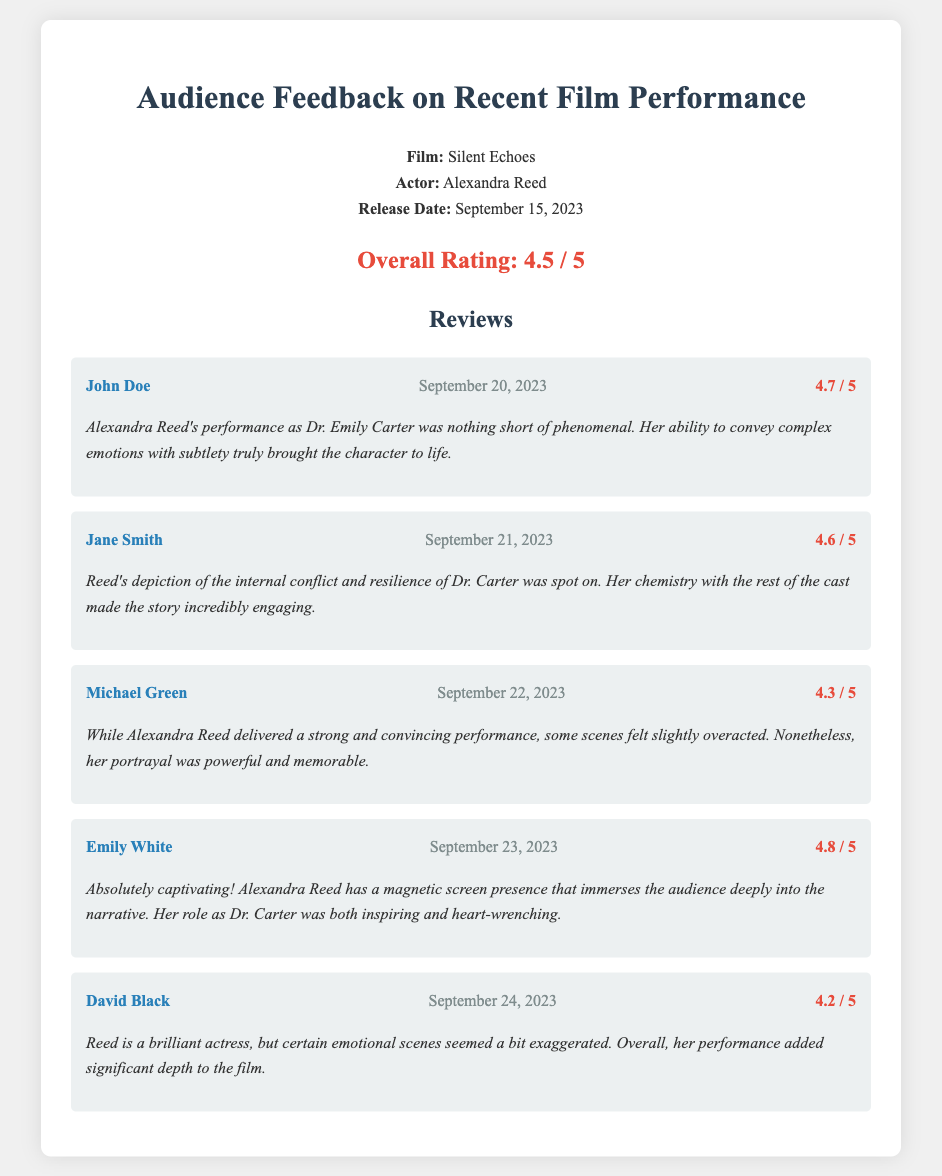What is the name of the film? The film title is mentioned in the document as "Silent Echoes."
Answer: Silent Echoes Who played the role of Dr. Emily Carter? The document specifies that Alexandra Reed played the role of Dr. Emily Carter.
Answer: Alexandra Reed What is the overall rating of Alexandra Reed's performance? The overall rating is explicitly stated in the document as 4.5 out of 5.
Answer: 4.5 / 5 Which reviewer gave the highest rating? The ratings provided show that Emily White gave the highest rating of 4.8 out of 5.
Answer: Emily White What date was the film released? The release date of the film is clearly identified as September 15, 2023.
Answer: September 15, 2023 How many reviews are included in the document? The document provides a total of five reviews from different reviewers.
Answer: Five What was a common criticism mentioned in the reviews? Multiple reviews indicated that some emotional scenes felt exaggerated, highlighting a common aspect of critique.
Answer: Exaggerated emotional scenes Which review specifically mentioned "magnetic screen presence"? The comment mentioning "magnetic screen presence" comes from Emily White's review.
Answer: Emily White What is a key theme noted in the audience reviews about Alexandra Reed's performance? Many reviews highlight the theme of conveying complex emotions and character depth in Alexandra Reed's portrayal.
Answer: Complex emotions and character depth 